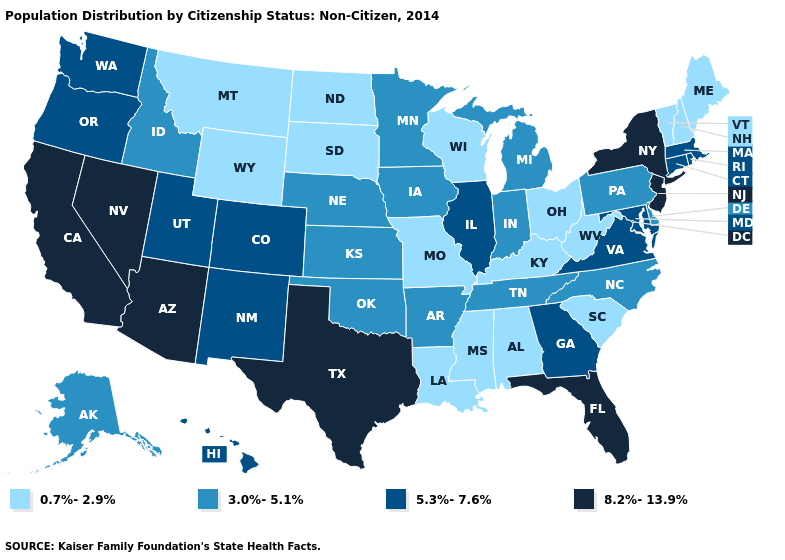Among the states that border Oregon , does California have the lowest value?
Write a very short answer. No. Among the states that border Colorado , which have the highest value?
Answer briefly. Arizona. What is the value of Arkansas?
Concise answer only. 3.0%-5.1%. What is the highest value in states that border Illinois?
Answer briefly. 3.0%-5.1%. Is the legend a continuous bar?
Be succinct. No. Among the states that border Vermont , does Massachusetts have the highest value?
Concise answer only. No. Which states have the lowest value in the West?
Concise answer only. Montana, Wyoming. What is the value of Oregon?
Keep it brief. 5.3%-7.6%. Which states hav the highest value in the South?
Give a very brief answer. Florida, Texas. Name the states that have a value in the range 0.7%-2.9%?
Answer briefly. Alabama, Kentucky, Louisiana, Maine, Mississippi, Missouri, Montana, New Hampshire, North Dakota, Ohio, South Carolina, South Dakota, Vermont, West Virginia, Wisconsin, Wyoming. What is the value of South Carolina?
Answer briefly. 0.7%-2.9%. Name the states that have a value in the range 0.7%-2.9%?
Keep it brief. Alabama, Kentucky, Louisiana, Maine, Mississippi, Missouri, Montana, New Hampshire, North Dakota, Ohio, South Carolina, South Dakota, Vermont, West Virginia, Wisconsin, Wyoming. What is the highest value in the USA?
Give a very brief answer. 8.2%-13.9%. Does New Hampshire have the same value as Montana?
Short answer required. Yes. Among the states that border Kansas , does Nebraska have the lowest value?
Write a very short answer. No. 